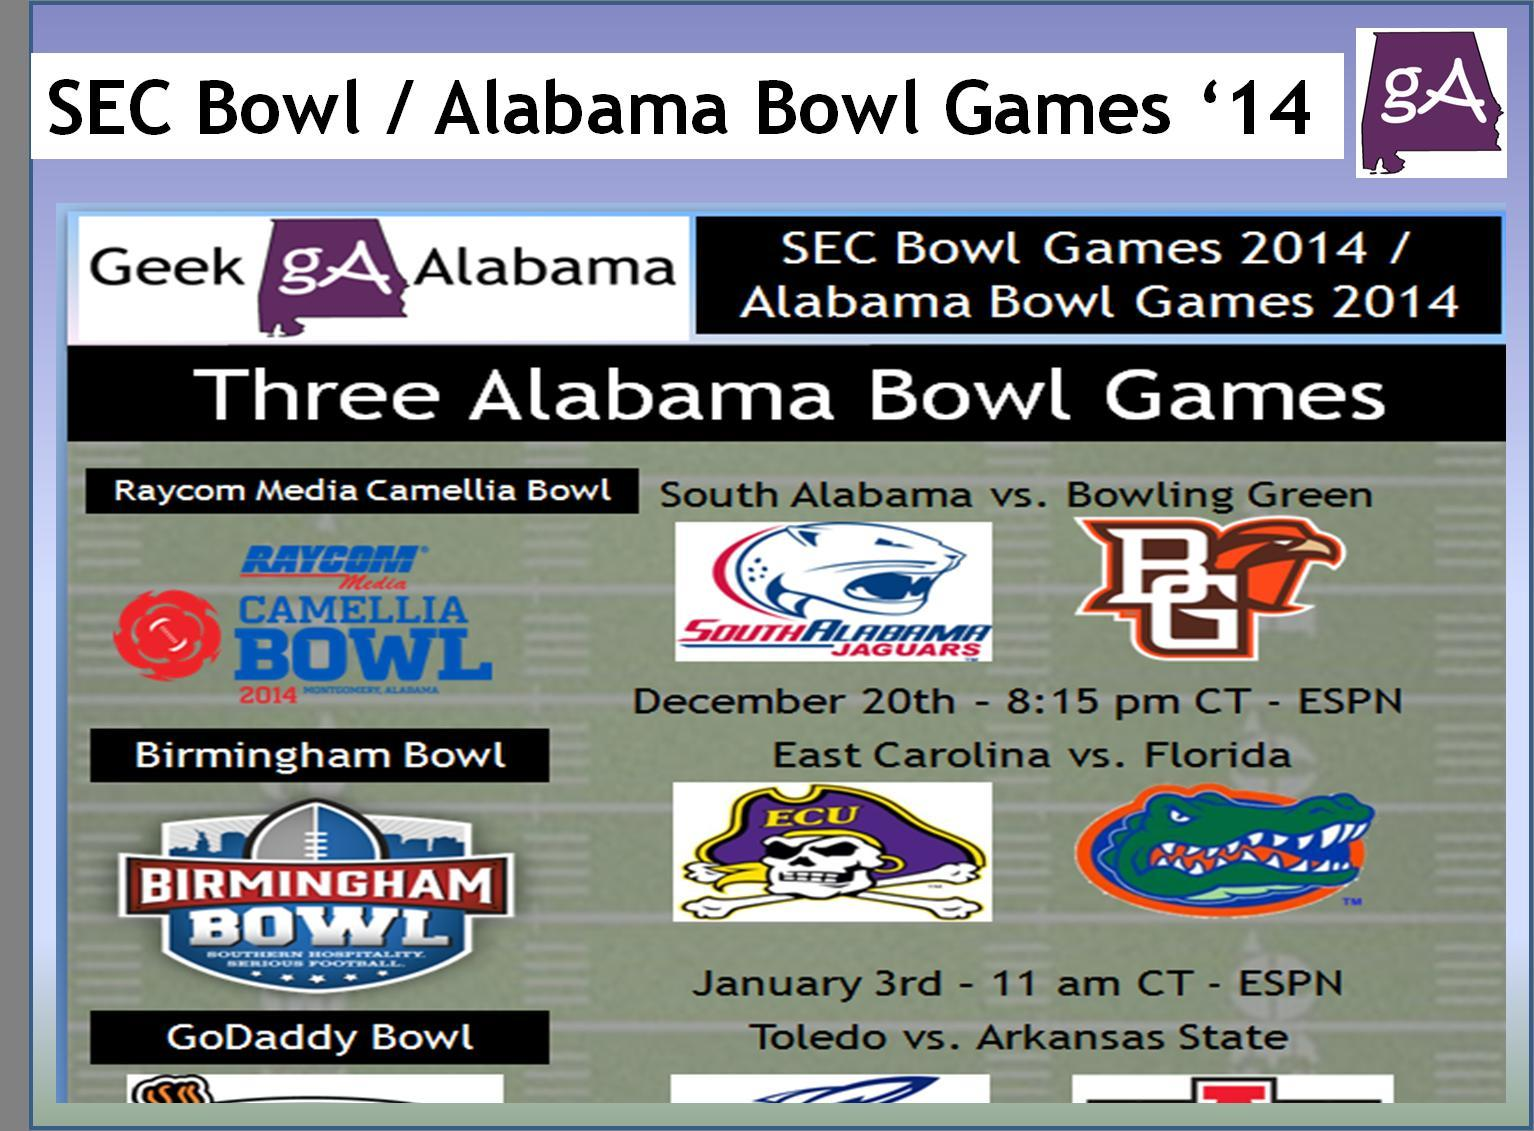On which channel will the Raycom Media Camelia Bowl be broadcast?
Answer the question with a short phrase. ESPN When is the East Carolina vs Florida match? January 3rd The match on January 3rd is between which teams? East Carolina vs. Florida When is the South Alabama vs Bowling Green match? December 20th - 8:15 pm CT The match on 20th December is between which two teams? South Alabama vs. Bowling Green At what time will the Birmingham Bowl match be broadcast? 11 am CT On which channel will the Birmingham Bowl be broadcast? ESPN When is the Raycom Media Camelia Bowl match? December 20th - 8:15 pm CT At what time will the Raycom Media Camellia Bowl match be broadcast? 8:15 pm CT On which day will the Birmingham Bowl match be held? January 3rd 